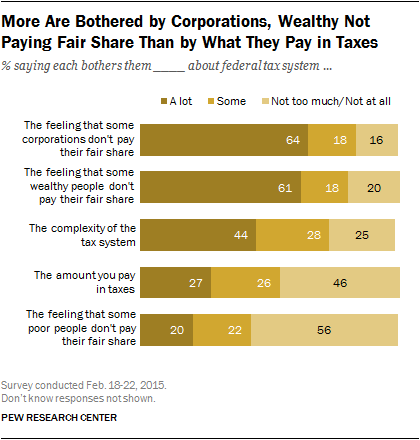List a handful of essential elements in this visual. The category with the highest percentage of a lot is likely the one that corporations don't pay their fair share in. The number of categories displayed in the graph is five. 